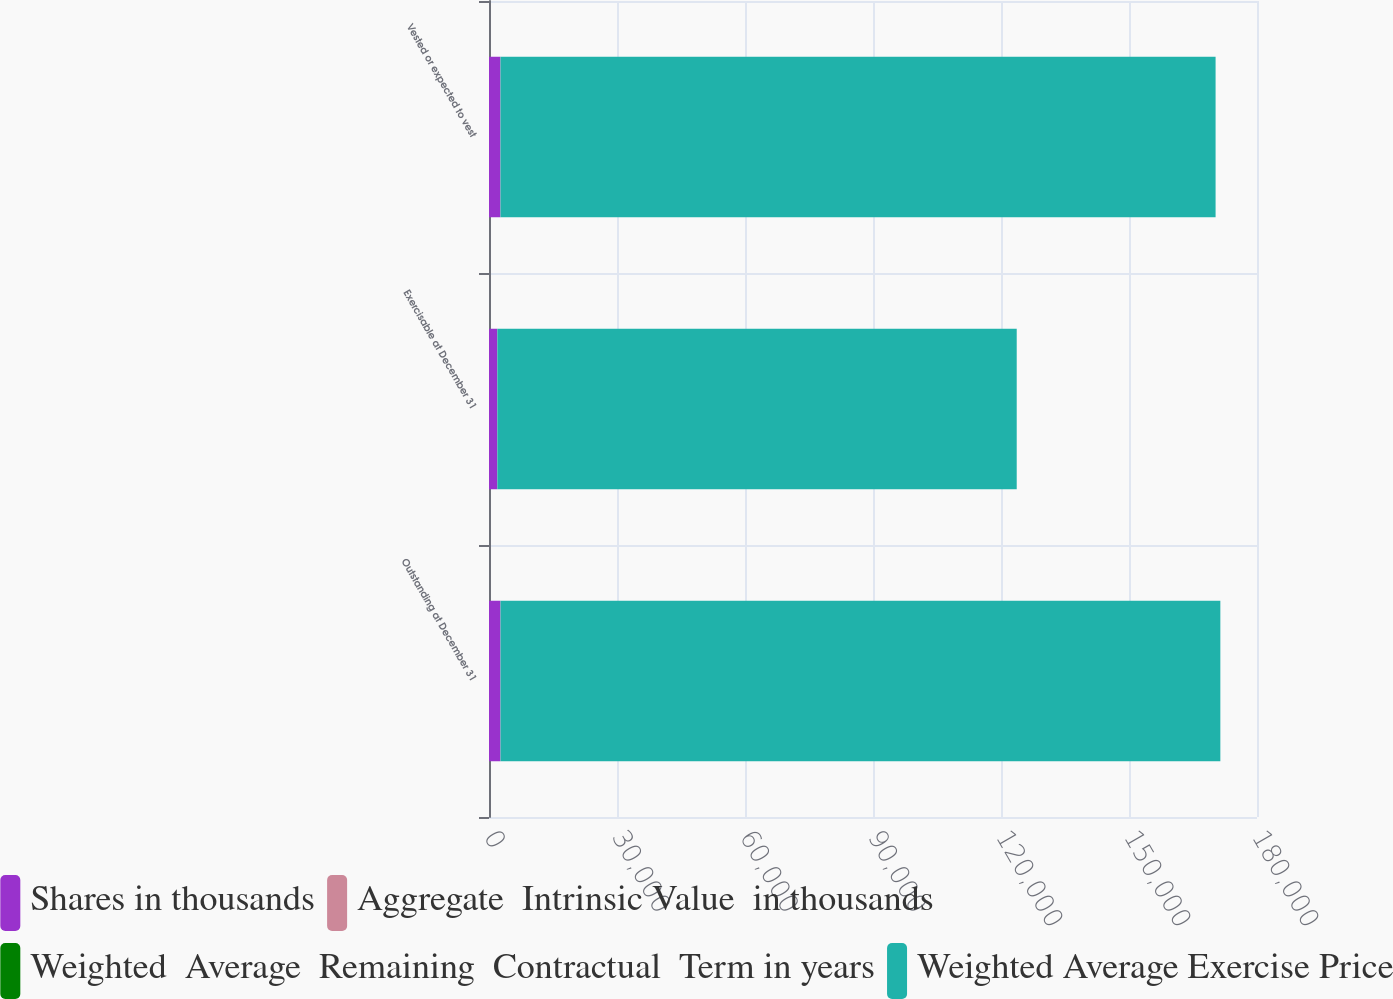Convert chart to OTSL. <chart><loc_0><loc_0><loc_500><loc_500><stacked_bar_chart><ecel><fcel>Outstanding at December 31<fcel>Exercisable at December 31<fcel>Vested or expected to vest<nl><fcel>Shares in thousands<fcel>2671<fcel>1933<fcel>2662<nl><fcel>Aggregate  Intrinsic Value  in thousands<fcel>28.65<fcel>28.66<fcel>28.52<nl><fcel>Weighted  Average  Remaining  Contractual  Term in years<fcel>3.48<fcel>2.68<fcel>3.45<nl><fcel>Weighted Average Exercise Price<fcel>168706<fcel>121722<fcel>167600<nl></chart> 